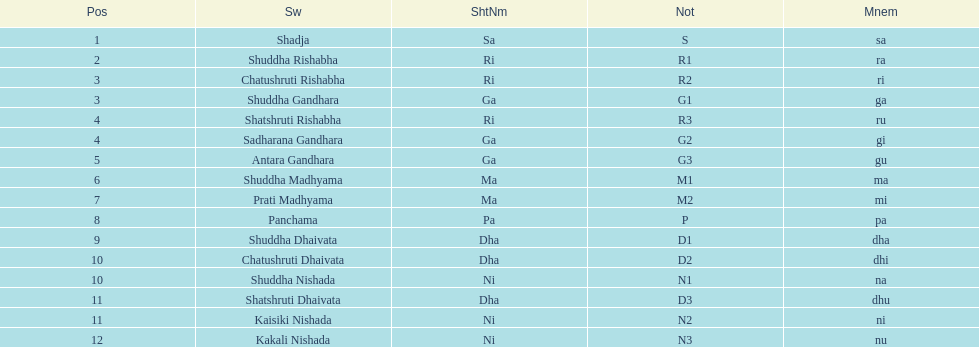Which swara follows immediately after antara gandhara? Shuddha Madhyama. 